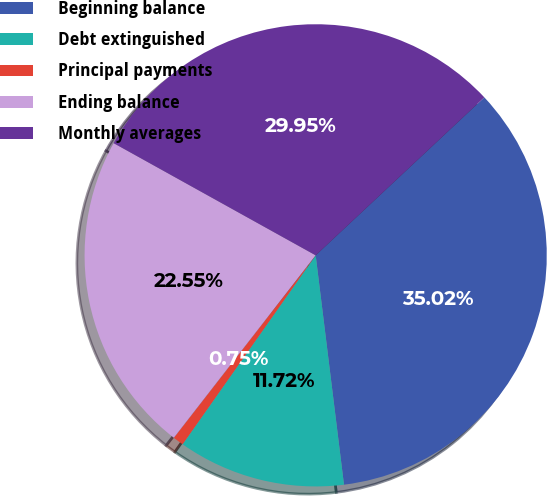<chart> <loc_0><loc_0><loc_500><loc_500><pie_chart><fcel>Beginning balance<fcel>Debt extinguished<fcel>Principal payments<fcel>Ending balance<fcel>Monthly averages<nl><fcel>35.02%<fcel>11.72%<fcel>0.75%<fcel>22.55%<fcel>29.95%<nl></chart> 